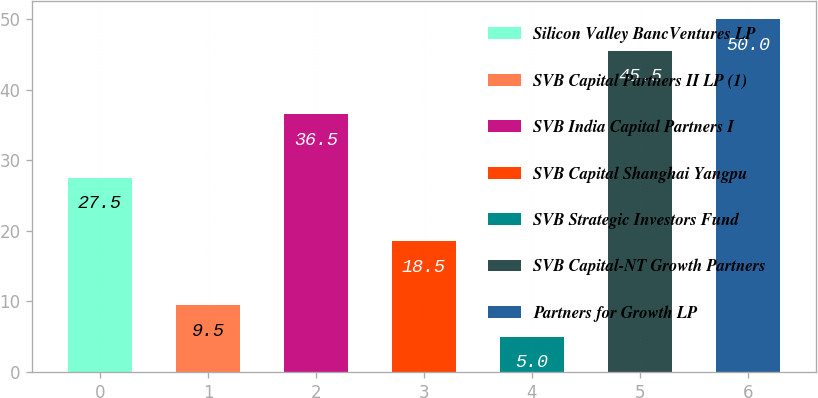Convert chart to OTSL. <chart><loc_0><loc_0><loc_500><loc_500><bar_chart><fcel>Silicon Valley BancVentures LP<fcel>SVB Capital Partners II LP (1)<fcel>SVB India Capital Partners I<fcel>SVB Capital Shanghai Yangpu<fcel>SVB Strategic Investors Fund<fcel>SVB Capital-NT Growth Partners<fcel>Partners for Growth LP<nl><fcel>27.5<fcel>9.5<fcel>36.5<fcel>18.5<fcel>5<fcel>45.5<fcel>50<nl></chart> 